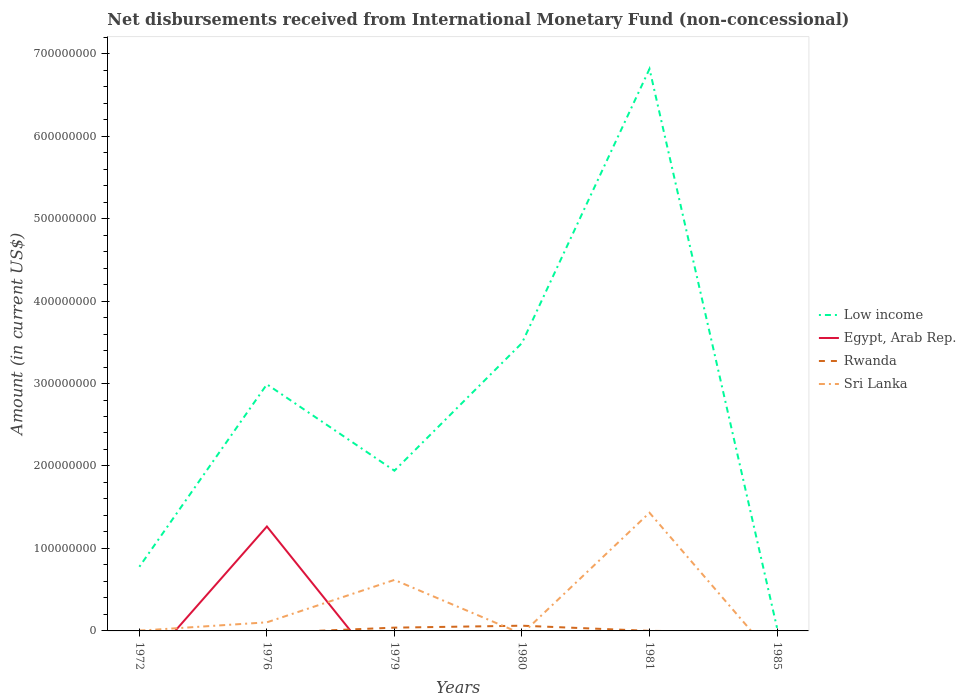What is the total amount of disbursements received from International Monetary Fund in Low income in the graph?
Make the answer very short. -2.21e+08. What is the difference between the highest and the second highest amount of disbursements received from International Monetary Fund in Rwanda?
Provide a short and direct response. 6.33e+06. What is the difference between two consecutive major ticks on the Y-axis?
Your answer should be very brief. 1.00e+08. Does the graph contain any zero values?
Your response must be concise. Yes. Where does the legend appear in the graph?
Offer a terse response. Center right. What is the title of the graph?
Ensure brevity in your answer.  Net disbursements received from International Monetary Fund (non-concessional). What is the label or title of the X-axis?
Your response must be concise. Years. What is the Amount (in current US$) in Low income in 1972?
Offer a terse response. 7.78e+07. What is the Amount (in current US$) of Rwanda in 1972?
Offer a terse response. 7.60e+04. What is the Amount (in current US$) of Sri Lanka in 1972?
Your answer should be very brief. 3.15e+05. What is the Amount (in current US$) of Low income in 1976?
Your answer should be very brief. 2.99e+08. What is the Amount (in current US$) in Egypt, Arab Rep. in 1976?
Provide a short and direct response. 1.27e+08. What is the Amount (in current US$) in Rwanda in 1976?
Ensure brevity in your answer.  0. What is the Amount (in current US$) in Sri Lanka in 1976?
Keep it short and to the point. 1.04e+07. What is the Amount (in current US$) of Low income in 1979?
Give a very brief answer. 1.94e+08. What is the Amount (in current US$) of Egypt, Arab Rep. in 1979?
Your answer should be compact. 0. What is the Amount (in current US$) in Rwanda in 1979?
Provide a short and direct response. 3.98e+06. What is the Amount (in current US$) in Sri Lanka in 1979?
Offer a very short reply. 6.18e+07. What is the Amount (in current US$) of Low income in 1980?
Give a very brief answer. 3.49e+08. What is the Amount (in current US$) in Egypt, Arab Rep. in 1980?
Offer a terse response. 0. What is the Amount (in current US$) in Rwanda in 1980?
Your response must be concise. 6.33e+06. What is the Amount (in current US$) in Sri Lanka in 1980?
Your answer should be compact. 0. What is the Amount (in current US$) in Low income in 1981?
Your response must be concise. 6.81e+08. What is the Amount (in current US$) in Rwanda in 1981?
Offer a terse response. 8.50e+04. What is the Amount (in current US$) in Sri Lanka in 1981?
Your response must be concise. 1.43e+08. What is the Amount (in current US$) in Low income in 1985?
Ensure brevity in your answer.  3.79e+06. What is the Amount (in current US$) of Egypt, Arab Rep. in 1985?
Offer a very short reply. 0. Across all years, what is the maximum Amount (in current US$) of Low income?
Give a very brief answer. 6.81e+08. Across all years, what is the maximum Amount (in current US$) of Egypt, Arab Rep.?
Your response must be concise. 1.27e+08. Across all years, what is the maximum Amount (in current US$) of Rwanda?
Provide a succinct answer. 6.33e+06. Across all years, what is the maximum Amount (in current US$) in Sri Lanka?
Give a very brief answer. 1.43e+08. Across all years, what is the minimum Amount (in current US$) in Low income?
Give a very brief answer. 3.79e+06. Across all years, what is the minimum Amount (in current US$) in Egypt, Arab Rep.?
Offer a very short reply. 0. Across all years, what is the minimum Amount (in current US$) of Rwanda?
Ensure brevity in your answer.  0. What is the total Amount (in current US$) in Low income in the graph?
Your response must be concise. 1.61e+09. What is the total Amount (in current US$) of Egypt, Arab Rep. in the graph?
Make the answer very short. 1.27e+08. What is the total Amount (in current US$) of Rwanda in the graph?
Your answer should be compact. 1.05e+07. What is the total Amount (in current US$) in Sri Lanka in the graph?
Offer a very short reply. 2.16e+08. What is the difference between the Amount (in current US$) in Low income in 1972 and that in 1976?
Keep it short and to the point. -2.21e+08. What is the difference between the Amount (in current US$) of Sri Lanka in 1972 and that in 1976?
Your answer should be very brief. -1.01e+07. What is the difference between the Amount (in current US$) in Low income in 1972 and that in 1979?
Your answer should be compact. -1.16e+08. What is the difference between the Amount (in current US$) of Rwanda in 1972 and that in 1979?
Give a very brief answer. -3.90e+06. What is the difference between the Amount (in current US$) in Sri Lanka in 1972 and that in 1979?
Your answer should be compact. -6.15e+07. What is the difference between the Amount (in current US$) of Low income in 1972 and that in 1980?
Offer a terse response. -2.71e+08. What is the difference between the Amount (in current US$) of Rwanda in 1972 and that in 1980?
Your answer should be very brief. -6.26e+06. What is the difference between the Amount (in current US$) of Low income in 1972 and that in 1981?
Give a very brief answer. -6.04e+08. What is the difference between the Amount (in current US$) in Rwanda in 1972 and that in 1981?
Your answer should be very brief. -9000. What is the difference between the Amount (in current US$) of Sri Lanka in 1972 and that in 1981?
Give a very brief answer. -1.43e+08. What is the difference between the Amount (in current US$) in Low income in 1972 and that in 1985?
Offer a terse response. 7.40e+07. What is the difference between the Amount (in current US$) of Low income in 1976 and that in 1979?
Provide a succinct answer. 1.05e+08. What is the difference between the Amount (in current US$) in Sri Lanka in 1976 and that in 1979?
Make the answer very short. -5.14e+07. What is the difference between the Amount (in current US$) of Low income in 1976 and that in 1980?
Offer a very short reply. -5.00e+07. What is the difference between the Amount (in current US$) in Low income in 1976 and that in 1981?
Ensure brevity in your answer.  -3.82e+08. What is the difference between the Amount (in current US$) of Sri Lanka in 1976 and that in 1981?
Make the answer very short. -1.33e+08. What is the difference between the Amount (in current US$) of Low income in 1976 and that in 1985?
Offer a terse response. 2.95e+08. What is the difference between the Amount (in current US$) in Low income in 1979 and that in 1980?
Give a very brief answer. -1.55e+08. What is the difference between the Amount (in current US$) in Rwanda in 1979 and that in 1980?
Your answer should be compact. -2.36e+06. What is the difference between the Amount (in current US$) of Low income in 1979 and that in 1981?
Offer a terse response. -4.87e+08. What is the difference between the Amount (in current US$) of Rwanda in 1979 and that in 1981?
Your answer should be compact. 3.89e+06. What is the difference between the Amount (in current US$) in Sri Lanka in 1979 and that in 1981?
Keep it short and to the point. -8.15e+07. What is the difference between the Amount (in current US$) in Low income in 1979 and that in 1985?
Make the answer very short. 1.90e+08. What is the difference between the Amount (in current US$) in Low income in 1980 and that in 1981?
Provide a short and direct response. -3.32e+08. What is the difference between the Amount (in current US$) in Rwanda in 1980 and that in 1981?
Your answer should be very brief. 6.25e+06. What is the difference between the Amount (in current US$) in Low income in 1980 and that in 1985?
Offer a very short reply. 3.45e+08. What is the difference between the Amount (in current US$) in Low income in 1981 and that in 1985?
Keep it short and to the point. 6.78e+08. What is the difference between the Amount (in current US$) of Low income in 1972 and the Amount (in current US$) of Egypt, Arab Rep. in 1976?
Your response must be concise. -4.88e+07. What is the difference between the Amount (in current US$) in Low income in 1972 and the Amount (in current US$) in Sri Lanka in 1976?
Provide a short and direct response. 6.74e+07. What is the difference between the Amount (in current US$) in Rwanda in 1972 and the Amount (in current US$) in Sri Lanka in 1976?
Ensure brevity in your answer.  -1.04e+07. What is the difference between the Amount (in current US$) of Low income in 1972 and the Amount (in current US$) of Rwanda in 1979?
Your answer should be very brief. 7.38e+07. What is the difference between the Amount (in current US$) of Low income in 1972 and the Amount (in current US$) of Sri Lanka in 1979?
Ensure brevity in your answer.  1.60e+07. What is the difference between the Amount (in current US$) of Rwanda in 1972 and the Amount (in current US$) of Sri Lanka in 1979?
Provide a succinct answer. -6.18e+07. What is the difference between the Amount (in current US$) of Low income in 1972 and the Amount (in current US$) of Rwanda in 1980?
Offer a terse response. 7.15e+07. What is the difference between the Amount (in current US$) of Low income in 1972 and the Amount (in current US$) of Rwanda in 1981?
Offer a terse response. 7.77e+07. What is the difference between the Amount (in current US$) of Low income in 1972 and the Amount (in current US$) of Sri Lanka in 1981?
Offer a very short reply. -6.55e+07. What is the difference between the Amount (in current US$) of Rwanda in 1972 and the Amount (in current US$) of Sri Lanka in 1981?
Make the answer very short. -1.43e+08. What is the difference between the Amount (in current US$) of Low income in 1976 and the Amount (in current US$) of Rwanda in 1979?
Offer a terse response. 2.95e+08. What is the difference between the Amount (in current US$) of Low income in 1976 and the Amount (in current US$) of Sri Lanka in 1979?
Offer a very short reply. 2.37e+08. What is the difference between the Amount (in current US$) in Egypt, Arab Rep. in 1976 and the Amount (in current US$) in Rwanda in 1979?
Make the answer very short. 1.23e+08. What is the difference between the Amount (in current US$) of Egypt, Arab Rep. in 1976 and the Amount (in current US$) of Sri Lanka in 1979?
Your answer should be very brief. 6.48e+07. What is the difference between the Amount (in current US$) in Low income in 1976 and the Amount (in current US$) in Rwanda in 1980?
Ensure brevity in your answer.  2.93e+08. What is the difference between the Amount (in current US$) in Egypt, Arab Rep. in 1976 and the Amount (in current US$) in Rwanda in 1980?
Ensure brevity in your answer.  1.20e+08. What is the difference between the Amount (in current US$) in Low income in 1976 and the Amount (in current US$) in Rwanda in 1981?
Provide a succinct answer. 2.99e+08. What is the difference between the Amount (in current US$) in Low income in 1976 and the Amount (in current US$) in Sri Lanka in 1981?
Your answer should be compact. 1.56e+08. What is the difference between the Amount (in current US$) in Egypt, Arab Rep. in 1976 and the Amount (in current US$) in Rwanda in 1981?
Provide a short and direct response. 1.27e+08. What is the difference between the Amount (in current US$) of Egypt, Arab Rep. in 1976 and the Amount (in current US$) of Sri Lanka in 1981?
Your answer should be compact. -1.67e+07. What is the difference between the Amount (in current US$) in Low income in 1979 and the Amount (in current US$) in Rwanda in 1980?
Ensure brevity in your answer.  1.88e+08. What is the difference between the Amount (in current US$) in Low income in 1979 and the Amount (in current US$) in Rwanda in 1981?
Your answer should be compact. 1.94e+08. What is the difference between the Amount (in current US$) in Low income in 1979 and the Amount (in current US$) in Sri Lanka in 1981?
Provide a short and direct response. 5.10e+07. What is the difference between the Amount (in current US$) of Rwanda in 1979 and the Amount (in current US$) of Sri Lanka in 1981?
Provide a short and direct response. -1.39e+08. What is the difference between the Amount (in current US$) in Low income in 1980 and the Amount (in current US$) in Rwanda in 1981?
Your response must be concise. 3.49e+08. What is the difference between the Amount (in current US$) in Low income in 1980 and the Amount (in current US$) in Sri Lanka in 1981?
Give a very brief answer. 2.06e+08. What is the difference between the Amount (in current US$) in Rwanda in 1980 and the Amount (in current US$) in Sri Lanka in 1981?
Provide a succinct answer. -1.37e+08. What is the average Amount (in current US$) in Low income per year?
Offer a terse response. 2.68e+08. What is the average Amount (in current US$) of Egypt, Arab Rep. per year?
Make the answer very short. 2.11e+07. What is the average Amount (in current US$) in Rwanda per year?
Keep it short and to the point. 1.74e+06. What is the average Amount (in current US$) in Sri Lanka per year?
Your answer should be compact. 3.60e+07. In the year 1972, what is the difference between the Amount (in current US$) of Low income and Amount (in current US$) of Rwanda?
Provide a succinct answer. 7.77e+07. In the year 1972, what is the difference between the Amount (in current US$) of Low income and Amount (in current US$) of Sri Lanka?
Ensure brevity in your answer.  7.75e+07. In the year 1972, what is the difference between the Amount (in current US$) in Rwanda and Amount (in current US$) in Sri Lanka?
Provide a succinct answer. -2.39e+05. In the year 1976, what is the difference between the Amount (in current US$) of Low income and Amount (in current US$) of Egypt, Arab Rep.?
Provide a succinct answer. 1.72e+08. In the year 1976, what is the difference between the Amount (in current US$) of Low income and Amount (in current US$) of Sri Lanka?
Give a very brief answer. 2.89e+08. In the year 1976, what is the difference between the Amount (in current US$) of Egypt, Arab Rep. and Amount (in current US$) of Sri Lanka?
Give a very brief answer. 1.16e+08. In the year 1979, what is the difference between the Amount (in current US$) of Low income and Amount (in current US$) of Rwanda?
Offer a terse response. 1.90e+08. In the year 1979, what is the difference between the Amount (in current US$) in Low income and Amount (in current US$) in Sri Lanka?
Your answer should be very brief. 1.32e+08. In the year 1979, what is the difference between the Amount (in current US$) in Rwanda and Amount (in current US$) in Sri Lanka?
Your answer should be very brief. -5.79e+07. In the year 1980, what is the difference between the Amount (in current US$) of Low income and Amount (in current US$) of Rwanda?
Keep it short and to the point. 3.43e+08. In the year 1981, what is the difference between the Amount (in current US$) in Low income and Amount (in current US$) in Rwanda?
Provide a short and direct response. 6.81e+08. In the year 1981, what is the difference between the Amount (in current US$) of Low income and Amount (in current US$) of Sri Lanka?
Offer a terse response. 5.38e+08. In the year 1981, what is the difference between the Amount (in current US$) of Rwanda and Amount (in current US$) of Sri Lanka?
Make the answer very short. -1.43e+08. What is the ratio of the Amount (in current US$) in Low income in 1972 to that in 1976?
Provide a short and direct response. 0.26. What is the ratio of the Amount (in current US$) of Sri Lanka in 1972 to that in 1976?
Ensure brevity in your answer.  0.03. What is the ratio of the Amount (in current US$) in Low income in 1972 to that in 1979?
Offer a very short reply. 0.4. What is the ratio of the Amount (in current US$) of Rwanda in 1972 to that in 1979?
Provide a succinct answer. 0.02. What is the ratio of the Amount (in current US$) of Sri Lanka in 1972 to that in 1979?
Your answer should be very brief. 0.01. What is the ratio of the Amount (in current US$) of Low income in 1972 to that in 1980?
Your answer should be very brief. 0.22. What is the ratio of the Amount (in current US$) of Rwanda in 1972 to that in 1980?
Your answer should be compact. 0.01. What is the ratio of the Amount (in current US$) in Low income in 1972 to that in 1981?
Your response must be concise. 0.11. What is the ratio of the Amount (in current US$) of Rwanda in 1972 to that in 1981?
Your response must be concise. 0.89. What is the ratio of the Amount (in current US$) of Sri Lanka in 1972 to that in 1981?
Your answer should be very brief. 0. What is the ratio of the Amount (in current US$) in Low income in 1972 to that in 1985?
Offer a very short reply. 20.53. What is the ratio of the Amount (in current US$) of Low income in 1976 to that in 1979?
Ensure brevity in your answer.  1.54. What is the ratio of the Amount (in current US$) in Sri Lanka in 1976 to that in 1979?
Provide a short and direct response. 0.17. What is the ratio of the Amount (in current US$) of Low income in 1976 to that in 1980?
Give a very brief answer. 0.86. What is the ratio of the Amount (in current US$) of Low income in 1976 to that in 1981?
Ensure brevity in your answer.  0.44. What is the ratio of the Amount (in current US$) of Sri Lanka in 1976 to that in 1981?
Offer a very short reply. 0.07. What is the ratio of the Amount (in current US$) of Low income in 1976 to that in 1985?
Your answer should be very brief. 78.93. What is the ratio of the Amount (in current US$) of Low income in 1979 to that in 1980?
Give a very brief answer. 0.56. What is the ratio of the Amount (in current US$) in Rwanda in 1979 to that in 1980?
Offer a very short reply. 0.63. What is the ratio of the Amount (in current US$) of Low income in 1979 to that in 1981?
Your answer should be very brief. 0.29. What is the ratio of the Amount (in current US$) of Rwanda in 1979 to that in 1981?
Your response must be concise. 46.76. What is the ratio of the Amount (in current US$) of Sri Lanka in 1979 to that in 1981?
Ensure brevity in your answer.  0.43. What is the ratio of the Amount (in current US$) in Low income in 1979 to that in 1985?
Your response must be concise. 51.28. What is the ratio of the Amount (in current US$) in Low income in 1980 to that in 1981?
Ensure brevity in your answer.  0.51. What is the ratio of the Amount (in current US$) in Rwanda in 1980 to that in 1981?
Keep it short and to the point. 74.48. What is the ratio of the Amount (in current US$) in Low income in 1980 to that in 1985?
Your response must be concise. 92.13. What is the ratio of the Amount (in current US$) in Low income in 1981 to that in 1985?
Your answer should be very brief. 179.86. What is the difference between the highest and the second highest Amount (in current US$) in Low income?
Your answer should be compact. 3.32e+08. What is the difference between the highest and the second highest Amount (in current US$) of Rwanda?
Your answer should be compact. 2.36e+06. What is the difference between the highest and the second highest Amount (in current US$) in Sri Lanka?
Your response must be concise. 8.15e+07. What is the difference between the highest and the lowest Amount (in current US$) in Low income?
Ensure brevity in your answer.  6.78e+08. What is the difference between the highest and the lowest Amount (in current US$) in Egypt, Arab Rep.?
Make the answer very short. 1.27e+08. What is the difference between the highest and the lowest Amount (in current US$) of Rwanda?
Offer a terse response. 6.33e+06. What is the difference between the highest and the lowest Amount (in current US$) in Sri Lanka?
Offer a terse response. 1.43e+08. 